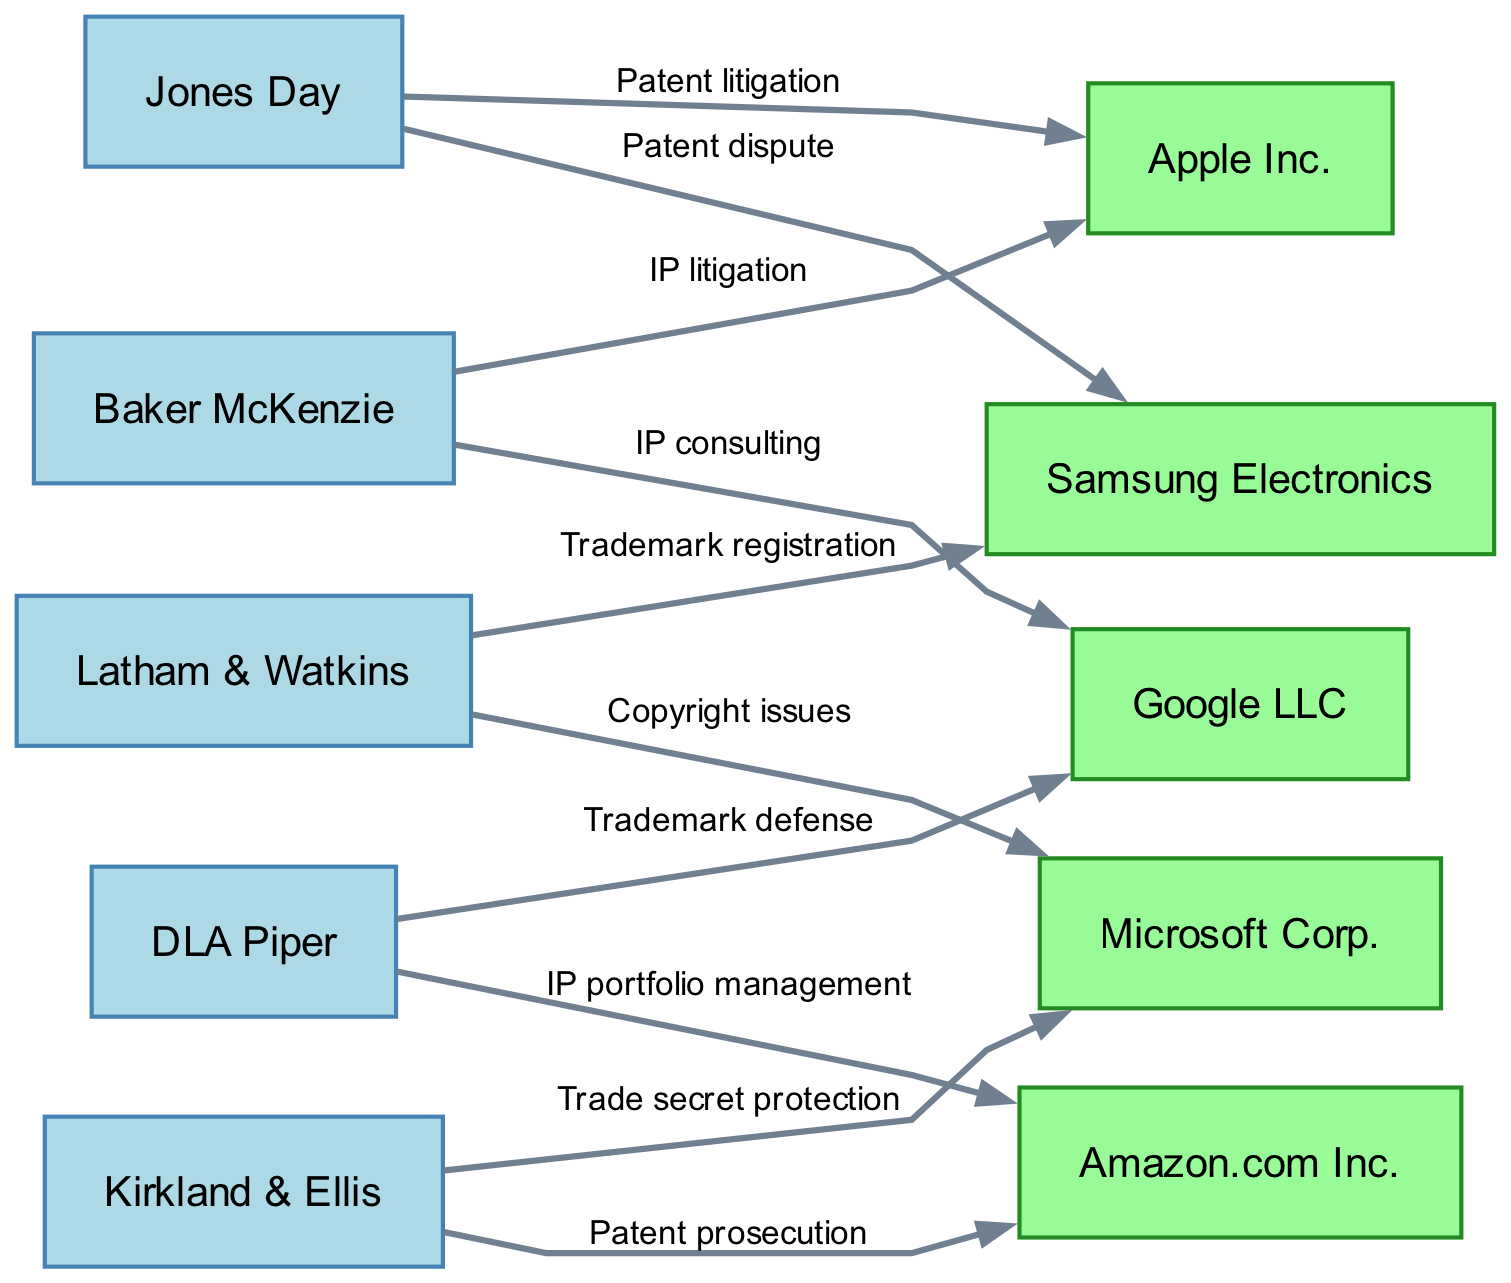What is the total number of law firms represented in the diagram? The diagram shows five distinct nodes under the category of law firms: Baker McKenzie, Jones Day, DLA Piper, Latham & Watkins, and Kirkland & Ellis. By counting these nodes, we confirm that there are five law firms.
Answer: 5 Which corporation is connected to DLA Piper? Examining the diagram, we find two connections from DLA Piper: one to Google LLC for trademark defense and another to Amazon.com Inc. for IP portfolio management. Therefore, both corporations are connected to DLA Piper.
Answer: Google LLC and Amazon.com Inc What type of legal service does Baker McKenzie provide to Apple Inc.? Looking closely at the directed edge between Baker McKenzie and Apple Inc., the label states "IP litigation," indicating the type of legal service this law firm provides to the corporation.
Answer: IP litigation How many total connections (edges) does Kirkland & Ellis have? There are two edges leading from Kirkland & Ellis: one to Amazon.com Inc. labeled "Patent prosecution" and another to Microsoft Corp. labeled "Trade secret protection." By counting these edges, we note that Kirkland & Ellis has two total connections.
Answer: 2 Which law firm provides IP consulting services? The diagram shows an edge from Baker McKenzie to Google LLC labeled "IP consulting." This indicates that Baker McKenzie is the law firm offering this specific service.
Answer: Baker McKenzie What is the relationship between Jones Day and Apple Inc.? In the diagram, there is an edge between Jones Day and Apple Inc. with the label "Patent litigation," specifying the nature of their connection.
Answer: Patent litigation Which corporation has the most connections in the diagram? By reviewing the edges for each corporation, we see that Apple Inc. is connected to both Baker McKenzie (IP litigation) and Jones Day (Patent litigation), giving it two total connections, the same as Amazon.com Inc. However, both have the same count of connections, which is the most in this context.
Answer: Apple Inc. and Amazon.com Inc What type of intellectual property issue is addressed by Latham & Watkins for Microsoft Corp.? Observing the diagram, the edge leading from Latham & Watkins to Microsoft Corp. is labeled "Copyright issues," indicating the specific intellectual property concern addressed by Latham & Watkins.
Answer: Copyright issues Which corporation does not have a direct connection to Baker McKenzie? Analyzing the connections, we see that Baker McKenzie is connected to Apple Inc. and Google LLC but not to Samsung Electronics, Microsoft Corp., or Amazon.com Inc. Therefore, the corporation without a direct connection is Samsung Electronics.
Answer: Samsung Electronics 